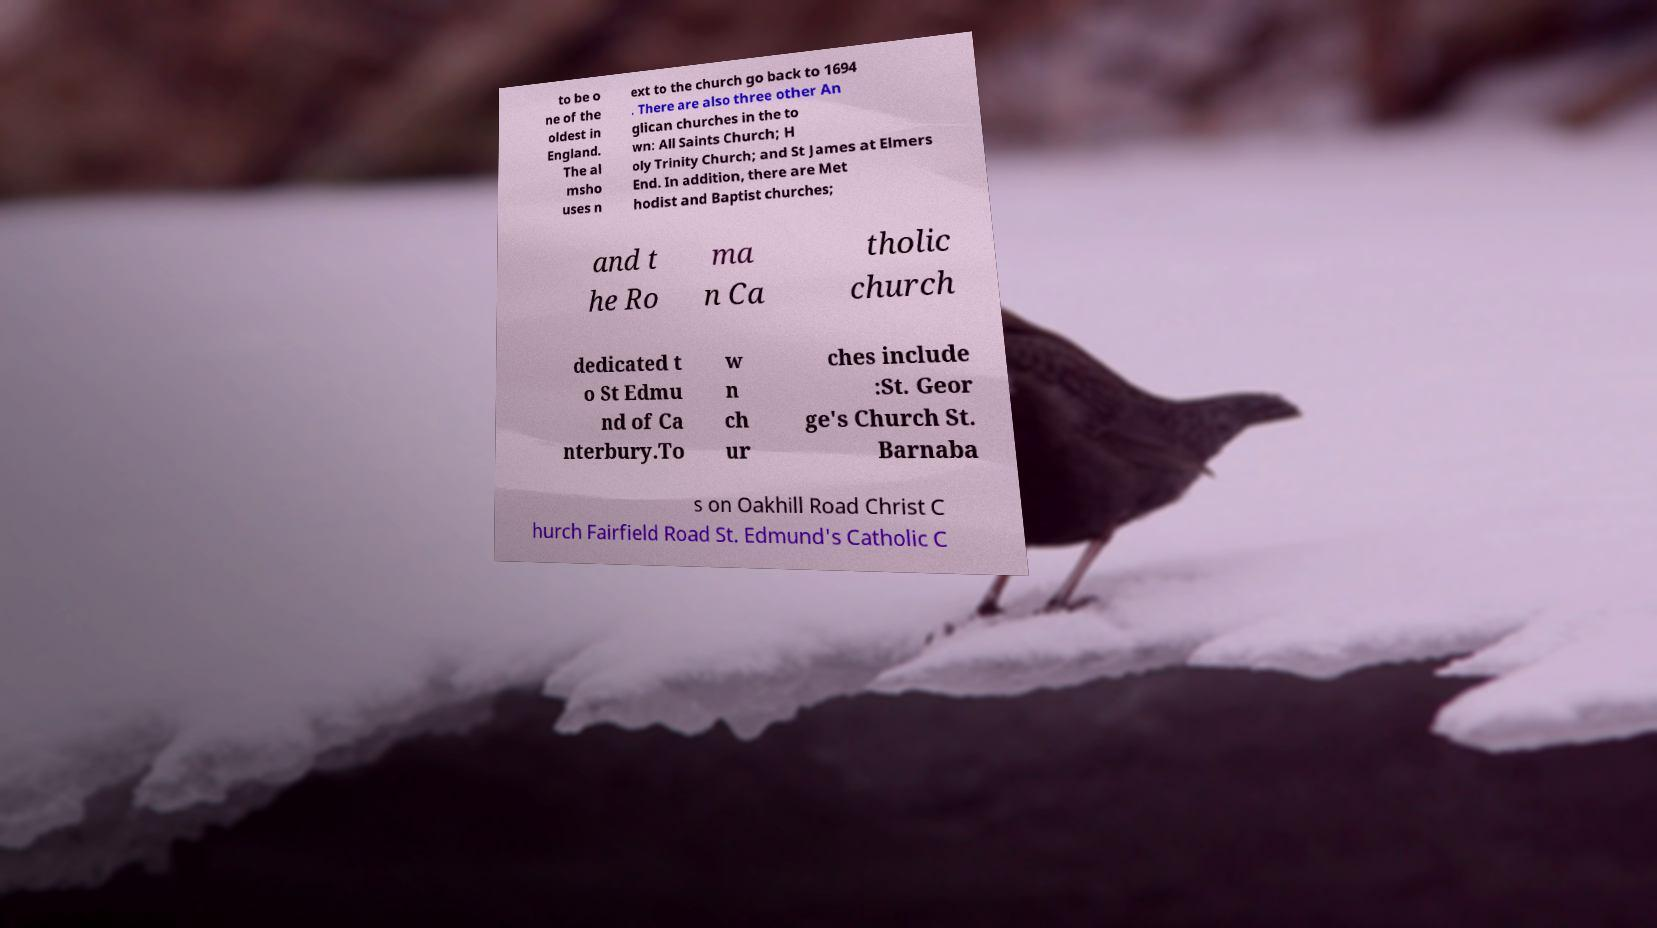Please identify and transcribe the text found in this image. to be o ne of the oldest in England. The al msho uses n ext to the church go back to 1694 . There are also three other An glican churches in the to wn: All Saints Church; H oly Trinity Church; and St James at Elmers End. In addition, there are Met hodist and Baptist churches; and t he Ro ma n Ca tholic church dedicated t o St Edmu nd of Ca nterbury.To w n ch ur ches include :St. Geor ge's Church St. Barnaba s on Oakhill Road Christ C hurch Fairfield Road St. Edmund's Catholic C 